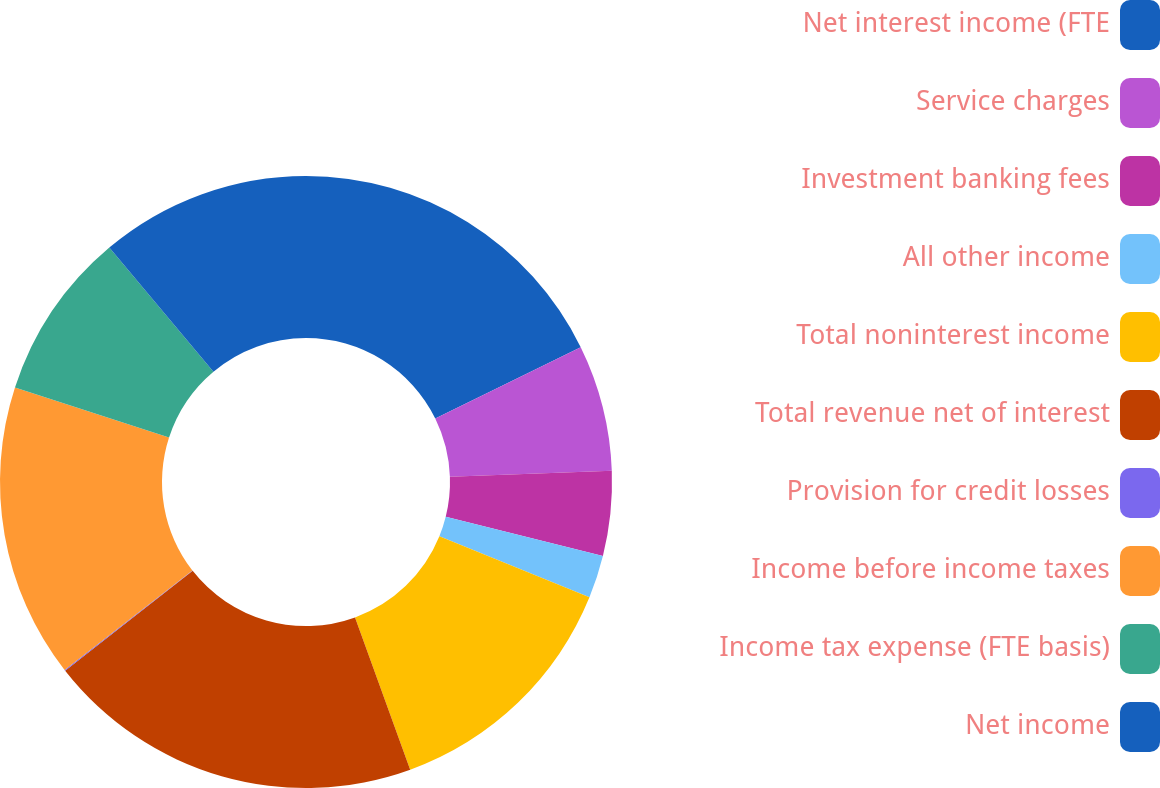Convert chart. <chart><loc_0><loc_0><loc_500><loc_500><pie_chart><fcel>Net interest income (FTE<fcel>Service charges<fcel>Investment banking fees<fcel>All other income<fcel>Total noninterest income<fcel>Total revenue net of interest<fcel>Provision for credit losses<fcel>Income before income taxes<fcel>Income tax expense (FTE basis)<fcel>Net income<nl><fcel>17.74%<fcel>6.68%<fcel>4.47%<fcel>2.26%<fcel>13.32%<fcel>19.95%<fcel>0.05%<fcel>15.53%<fcel>8.89%<fcel>11.11%<nl></chart> 